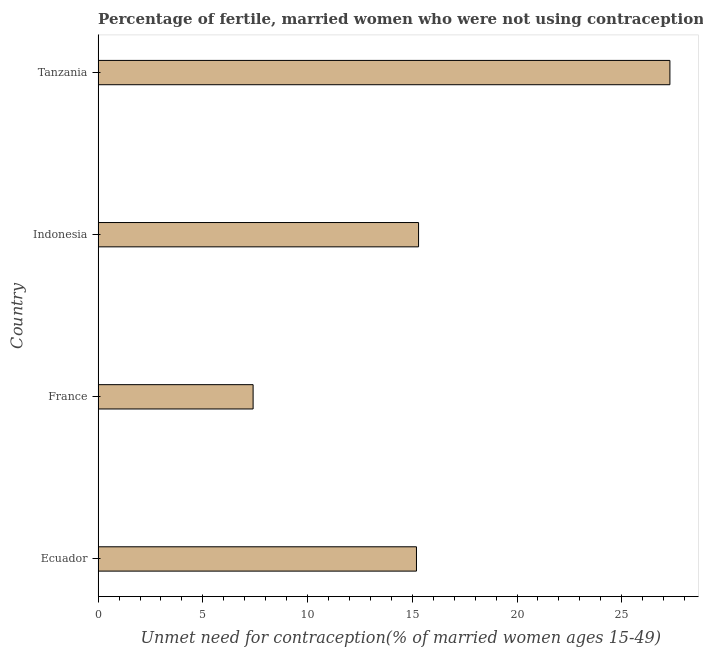Does the graph contain any zero values?
Your answer should be compact. No. What is the title of the graph?
Offer a very short reply. Percentage of fertile, married women who were not using contraception in 1994. What is the label or title of the X-axis?
Ensure brevity in your answer.   Unmet need for contraception(% of married women ages 15-49). What is the label or title of the Y-axis?
Your response must be concise. Country. Across all countries, what is the maximum number of married women who are not using contraception?
Offer a terse response. 27.3. Across all countries, what is the minimum number of married women who are not using contraception?
Ensure brevity in your answer.  7.4. In which country was the number of married women who are not using contraception maximum?
Offer a terse response. Tanzania. In which country was the number of married women who are not using contraception minimum?
Make the answer very short. France. What is the sum of the number of married women who are not using contraception?
Make the answer very short. 65.2. What is the difference between the number of married women who are not using contraception in Ecuador and France?
Provide a succinct answer. 7.8. What is the average number of married women who are not using contraception per country?
Your answer should be very brief. 16.3. What is the median number of married women who are not using contraception?
Give a very brief answer. 15.25. What is the ratio of the number of married women who are not using contraception in France to that in Tanzania?
Give a very brief answer. 0.27. Is the number of married women who are not using contraception in Ecuador less than that in France?
Provide a succinct answer. No. Is the difference between the number of married women who are not using contraception in France and Indonesia greater than the difference between any two countries?
Offer a very short reply. No. What is the difference between the highest and the second highest number of married women who are not using contraception?
Ensure brevity in your answer.  12. Is the sum of the number of married women who are not using contraception in France and Indonesia greater than the maximum number of married women who are not using contraception across all countries?
Your answer should be very brief. No. How many bars are there?
Provide a succinct answer. 4. Are the values on the major ticks of X-axis written in scientific E-notation?
Keep it short and to the point. No. What is the  Unmet need for contraception(% of married women ages 15-49) in France?
Ensure brevity in your answer.  7.4. What is the  Unmet need for contraception(% of married women ages 15-49) in Tanzania?
Give a very brief answer. 27.3. What is the difference between the  Unmet need for contraception(% of married women ages 15-49) in Ecuador and France?
Provide a succinct answer. 7.8. What is the difference between the  Unmet need for contraception(% of married women ages 15-49) in France and Tanzania?
Provide a short and direct response. -19.9. What is the ratio of the  Unmet need for contraception(% of married women ages 15-49) in Ecuador to that in France?
Offer a very short reply. 2.05. What is the ratio of the  Unmet need for contraception(% of married women ages 15-49) in Ecuador to that in Indonesia?
Your answer should be very brief. 0.99. What is the ratio of the  Unmet need for contraception(% of married women ages 15-49) in Ecuador to that in Tanzania?
Your answer should be compact. 0.56. What is the ratio of the  Unmet need for contraception(% of married women ages 15-49) in France to that in Indonesia?
Provide a succinct answer. 0.48. What is the ratio of the  Unmet need for contraception(% of married women ages 15-49) in France to that in Tanzania?
Provide a short and direct response. 0.27. What is the ratio of the  Unmet need for contraception(% of married women ages 15-49) in Indonesia to that in Tanzania?
Keep it short and to the point. 0.56. 